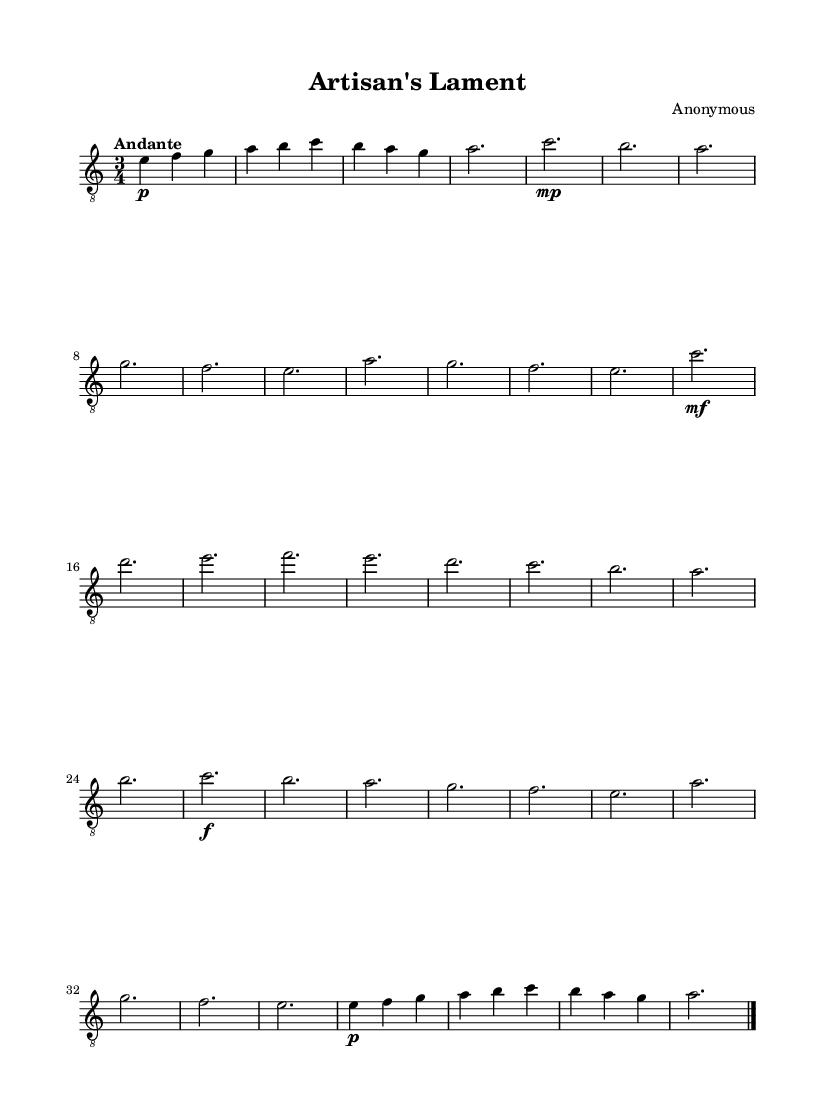What is the key signature of this music? The key signature is A minor, which has no sharps or flats. The presence of the G# and the absence of any accidentals indicates it is in the key of A minor.
Answer: A minor What is the time signature of this music? The time signature is 3/4, as indicated at the beginning of the score, showing that there are three beats per measure and a quarter note gets one beat.
Answer: 3/4 What is the tempo marking for this piece? The tempo marking is "Andante," indicating a moderate walking speed, which is typically around 76-108 beats per minute.
Answer: Andante How many sections are in the structure of this piece? The piece has five sections: Introduction, Section A, Section B, Section A', and Coda. Each section contributes to the overall form and thematic development of the music.
Answer: Five What dynamic marking is used at the beginning of Section A? The dynamic marking at the beginning of Section A is "mp," which stands for "mezzo piano," meaning moderately soft. This setting guides the performer on how to interpret the volume in that section.
Answer: mp In which section does the dynamic marking "f" first appear? The dynamic marking "f" first appears in Section A', indicating that this section should be played loudly, contrasting with the previous sections.
Answer: Section A' What is the last note of the piece? The last note of the piece is "a," which concludes the Coda and brings resolution to the composition. This is indicated by the note ending the final measure before the double bar line.
Answer: a 